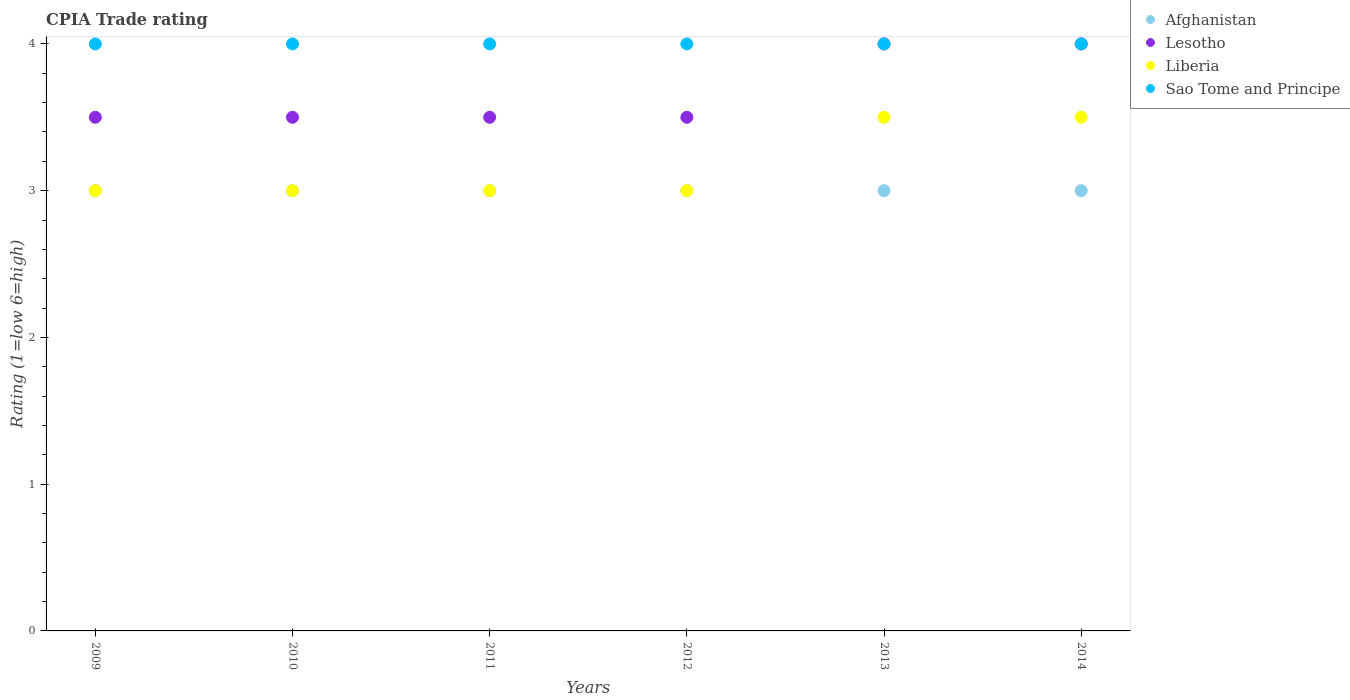How many different coloured dotlines are there?
Offer a terse response. 4. Across all years, what is the maximum CPIA rating in Sao Tome and Principe?
Provide a succinct answer. 4. Across all years, what is the minimum CPIA rating in Sao Tome and Principe?
Your answer should be compact. 4. In which year was the CPIA rating in Afghanistan maximum?
Provide a short and direct response. 2009. What is the total CPIA rating in Afghanistan in the graph?
Offer a terse response. 18. What is the difference between the CPIA rating in Lesotho in 2011 and that in 2014?
Ensure brevity in your answer.  -0.5. What is the difference between the CPIA rating in Lesotho in 2010 and the CPIA rating in Liberia in 2009?
Offer a very short reply. 0.5. In how many years, is the CPIA rating in Sao Tome and Principe greater than 0.6000000000000001?
Keep it short and to the point. 6. What is the ratio of the CPIA rating in Sao Tome and Principe in 2011 to that in 2012?
Offer a very short reply. 1. Is the difference between the CPIA rating in Lesotho in 2009 and 2011 greater than the difference between the CPIA rating in Afghanistan in 2009 and 2011?
Your answer should be compact. No. What is the difference between the highest and the lowest CPIA rating in Afghanistan?
Your response must be concise. 0. In how many years, is the CPIA rating in Liberia greater than the average CPIA rating in Liberia taken over all years?
Make the answer very short. 2. Does the CPIA rating in Afghanistan monotonically increase over the years?
Your answer should be very brief. No. How many years are there in the graph?
Give a very brief answer. 6. Does the graph contain grids?
Your answer should be compact. No. How many legend labels are there?
Offer a very short reply. 4. How are the legend labels stacked?
Offer a terse response. Vertical. What is the title of the graph?
Offer a very short reply. CPIA Trade rating. Does "Cyprus" appear as one of the legend labels in the graph?
Your answer should be very brief. No. What is the label or title of the X-axis?
Offer a very short reply. Years. What is the Rating (1=low 6=high) in Afghanistan in 2009?
Make the answer very short. 3. What is the Rating (1=low 6=high) of Liberia in 2009?
Provide a succinct answer. 3. What is the Rating (1=low 6=high) in Sao Tome and Principe in 2009?
Give a very brief answer. 4. What is the Rating (1=low 6=high) of Liberia in 2010?
Ensure brevity in your answer.  3. What is the Rating (1=low 6=high) of Lesotho in 2011?
Keep it short and to the point. 3.5. What is the Rating (1=low 6=high) of Liberia in 2011?
Your response must be concise. 3. What is the Rating (1=low 6=high) in Sao Tome and Principe in 2011?
Make the answer very short. 4. What is the Rating (1=low 6=high) of Afghanistan in 2012?
Give a very brief answer. 3. What is the Rating (1=low 6=high) in Lesotho in 2012?
Give a very brief answer. 3.5. What is the Rating (1=low 6=high) of Sao Tome and Principe in 2012?
Offer a very short reply. 4. What is the Rating (1=low 6=high) in Lesotho in 2013?
Your answer should be very brief. 4. What is the Rating (1=low 6=high) in Liberia in 2013?
Make the answer very short. 3.5. Across all years, what is the maximum Rating (1=low 6=high) of Afghanistan?
Make the answer very short. 3. Across all years, what is the maximum Rating (1=low 6=high) in Lesotho?
Provide a short and direct response. 4. Across all years, what is the maximum Rating (1=low 6=high) of Liberia?
Provide a short and direct response. 3.5. Across all years, what is the minimum Rating (1=low 6=high) of Lesotho?
Your response must be concise. 3.5. Across all years, what is the minimum Rating (1=low 6=high) in Sao Tome and Principe?
Keep it short and to the point. 4. What is the total Rating (1=low 6=high) in Afghanistan in the graph?
Offer a very short reply. 18. What is the difference between the Rating (1=low 6=high) of Afghanistan in 2009 and that in 2010?
Provide a succinct answer. 0. What is the difference between the Rating (1=low 6=high) of Liberia in 2009 and that in 2010?
Your answer should be compact. 0. What is the difference between the Rating (1=low 6=high) in Lesotho in 2009 and that in 2011?
Ensure brevity in your answer.  0. What is the difference between the Rating (1=low 6=high) in Liberia in 2009 and that in 2011?
Provide a succinct answer. 0. What is the difference between the Rating (1=low 6=high) in Sao Tome and Principe in 2009 and that in 2011?
Provide a short and direct response. 0. What is the difference between the Rating (1=low 6=high) in Afghanistan in 2009 and that in 2012?
Ensure brevity in your answer.  0. What is the difference between the Rating (1=low 6=high) of Sao Tome and Principe in 2009 and that in 2012?
Provide a succinct answer. 0. What is the difference between the Rating (1=low 6=high) in Afghanistan in 2009 and that in 2013?
Make the answer very short. 0. What is the difference between the Rating (1=low 6=high) of Liberia in 2009 and that in 2013?
Provide a succinct answer. -0.5. What is the difference between the Rating (1=low 6=high) of Sao Tome and Principe in 2009 and that in 2013?
Provide a succinct answer. 0. What is the difference between the Rating (1=low 6=high) of Afghanistan in 2009 and that in 2014?
Provide a short and direct response. 0. What is the difference between the Rating (1=low 6=high) in Afghanistan in 2010 and that in 2011?
Provide a succinct answer. 0. What is the difference between the Rating (1=low 6=high) of Afghanistan in 2010 and that in 2012?
Ensure brevity in your answer.  0. What is the difference between the Rating (1=low 6=high) of Lesotho in 2010 and that in 2013?
Keep it short and to the point. -0.5. What is the difference between the Rating (1=low 6=high) in Sao Tome and Principe in 2010 and that in 2013?
Your response must be concise. 0. What is the difference between the Rating (1=low 6=high) in Sao Tome and Principe in 2010 and that in 2014?
Offer a terse response. 0. What is the difference between the Rating (1=low 6=high) in Sao Tome and Principe in 2011 and that in 2012?
Make the answer very short. 0. What is the difference between the Rating (1=low 6=high) in Afghanistan in 2011 and that in 2013?
Offer a very short reply. 0. What is the difference between the Rating (1=low 6=high) of Lesotho in 2011 and that in 2013?
Make the answer very short. -0.5. What is the difference between the Rating (1=low 6=high) of Afghanistan in 2011 and that in 2014?
Provide a short and direct response. 0. What is the difference between the Rating (1=low 6=high) in Liberia in 2011 and that in 2014?
Ensure brevity in your answer.  -0.5. What is the difference between the Rating (1=low 6=high) in Sao Tome and Principe in 2011 and that in 2014?
Keep it short and to the point. 0. What is the difference between the Rating (1=low 6=high) in Afghanistan in 2012 and that in 2014?
Give a very brief answer. 0. What is the difference between the Rating (1=low 6=high) of Liberia in 2012 and that in 2014?
Give a very brief answer. -0.5. What is the difference between the Rating (1=low 6=high) in Afghanistan in 2013 and that in 2014?
Offer a terse response. 0. What is the difference between the Rating (1=low 6=high) of Lesotho in 2013 and that in 2014?
Keep it short and to the point. 0. What is the difference between the Rating (1=low 6=high) in Sao Tome and Principe in 2013 and that in 2014?
Make the answer very short. 0. What is the difference between the Rating (1=low 6=high) in Afghanistan in 2009 and the Rating (1=low 6=high) in Lesotho in 2010?
Make the answer very short. -0.5. What is the difference between the Rating (1=low 6=high) in Afghanistan in 2009 and the Rating (1=low 6=high) in Sao Tome and Principe in 2010?
Keep it short and to the point. -1. What is the difference between the Rating (1=low 6=high) in Lesotho in 2009 and the Rating (1=low 6=high) in Liberia in 2010?
Make the answer very short. 0.5. What is the difference between the Rating (1=low 6=high) of Afghanistan in 2009 and the Rating (1=low 6=high) of Sao Tome and Principe in 2011?
Make the answer very short. -1. What is the difference between the Rating (1=low 6=high) in Lesotho in 2009 and the Rating (1=low 6=high) in Liberia in 2011?
Provide a succinct answer. 0.5. What is the difference between the Rating (1=low 6=high) of Lesotho in 2009 and the Rating (1=low 6=high) of Liberia in 2012?
Your response must be concise. 0.5. What is the difference between the Rating (1=low 6=high) in Afghanistan in 2009 and the Rating (1=low 6=high) in Lesotho in 2013?
Make the answer very short. -1. What is the difference between the Rating (1=low 6=high) of Lesotho in 2009 and the Rating (1=low 6=high) of Liberia in 2013?
Ensure brevity in your answer.  0. What is the difference between the Rating (1=low 6=high) of Liberia in 2009 and the Rating (1=low 6=high) of Sao Tome and Principe in 2013?
Offer a terse response. -1. What is the difference between the Rating (1=low 6=high) of Afghanistan in 2009 and the Rating (1=low 6=high) of Sao Tome and Principe in 2014?
Provide a succinct answer. -1. What is the difference between the Rating (1=low 6=high) of Lesotho in 2009 and the Rating (1=low 6=high) of Liberia in 2014?
Your answer should be very brief. 0. What is the difference between the Rating (1=low 6=high) in Lesotho in 2009 and the Rating (1=low 6=high) in Sao Tome and Principe in 2014?
Provide a short and direct response. -0.5. What is the difference between the Rating (1=low 6=high) in Liberia in 2009 and the Rating (1=low 6=high) in Sao Tome and Principe in 2014?
Keep it short and to the point. -1. What is the difference between the Rating (1=low 6=high) of Afghanistan in 2010 and the Rating (1=low 6=high) of Liberia in 2011?
Provide a short and direct response. 0. What is the difference between the Rating (1=low 6=high) of Liberia in 2010 and the Rating (1=low 6=high) of Sao Tome and Principe in 2011?
Offer a terse response. -1. What is the difference between the Rating (1=low 6=high) of Afghanistan in 2010 and the Rating (1=low 6=high) of Lesotho in 2012?
Ensure brevity in your answer.  -0.5. What is the difference between the Rating (1=low 6=high) in Afghanistan in 2010 and the Rating (1=low 6=high) in Sao Tome and Principe in 2012?
Offer a terse response. -1. What is the difference between the Rating (1=low 6=high) of Lesotho in 2010 and the Rating (1=low 6=high) of Liberia in 2012?
Offer a very short reply. 0.5. What is the difference between the Rating (1=low 6=high) of Lesotho in 2010 and the Rating (1=low 6=high) of Sao Tome and Principe in 2012?
Make the answer very short. -0.5. What is the difference between the Rating (1=low 6=high) in Liberia in 2010 and the Rating (1=low 6=high) in Sao Tome and Principe in 2012?
Offer a very short reply. -1. What is the difference between the Rating (1=low 6=high) in Afghanistan in 2010 and the Rating (1=low 6=high) in Liberia in 2013?
Provide a succinct answer. -0.5. What is the difference between the Rating (1=low 6=high) of Lesotho in 2010 and the Rating (1=low 6=high) of Sao Tome and Principe in 2013?
Your response must be concise. -0.5. What is the difference between the Rating (1=low 6=high) of Afghanistan in 2010 and the Rating (1=low 6=high) of Liberia in 2014?
Make the answer very short. -0.5. What is the difference between the Rating (1=low 6=high) in Afghanistan in 2011 and the Rating (1=low 6=high) in Sao Tome and Principe in 2012?
Your answer should be compact. -1. What is the difference between the Rating (1=low 6=high) in Lesotho in 2011 and the Rating (1=low 6=high) in Liberia in 2012?
Give a very brief answer. 0.5. What is the difference between the Rating (1=low 6=high) in Afghanistan in 2011 and the Rating (1=low 6=high) in Liberia in 2013?
Provide a succinct answer. -0.5. What is the difference between the Rating (1=low 6=high) in Lesotho in 2011 and the Rating (1=low 6=high) in Liberia in 2013?
Provide a short and direct response. 0. What is the difference between the Rating (1=low 6=high) in Lesotho in 2011 and the Rating (1=low 6=high) in Sao Tome and Principe in 2013?
Offer a terse response. -0.5. What is the difference between the Rating (1=low 6=high) of Liberia in 2011 and the Rating (1=low 6=high) of Sao Tome and Principe in 2013?
Keep it short and to the point. -1. What is the difference between the Rating (1=low 6=high) of Afghanistan in 2011 and the Rating (1=low 6=high) of Lesotho in 2014?
Provide a succinct answer. -1. What is the difference between the Rating (1=low 6=high) of Afghanistan in 2011 and the Rating (1=low 6=high) of Liberia in 2014?
Your answer should be very brief. -0.5. What is the difference between the Rating (1=low 6=high) of Afghanistan in 2011 and the Rating (1=low 6=high) of Sao Tome and Principe in 2014?
Give a very brief answer. -1. What is the difference between the Rating (1=low 6=high) in Lesotho in 2011 and the Rating (1=low 6=high) in Sao Tome and Principe in 2014?
Your response must be concise. -0.5. What is the difference between the Rating (1=low 6=high) in Afghanistan in 2012 and the Rating (1=low 6=high) in Sao Tome and Principe in 2013?
Make the answer very short. -1. What is the difference between the Rating (1=low 6=high) of Afghanistan in 2012 and the Rating (1=low 6=high) of Lesotho in 2014?
Your answer should be very brief. -1. What is the difference between the Rating (1=low 6=high) in Afghanistan in 2012 and the Rating (1=low 6=high) in Liberia in 2014?
Keep it short and to the point. -0.5. What is the difference between the Rating (1=low 6=high) in Lesotho in 2012 and the Rating (1=low 6=high) in Sao Tome and Principe in 2014?
Provide a succinct answer. -0.5. What is the difference between the Rating (1=low 6=high) of Liberia in 2013 and the Rating (1=low 6=high) of Sao Tome and Principe in 2014?
Provide a succinct answer. -0.5. What is the average Rating (1=low 6=high) of Lesotho per year?
Offer a terse response. 3.67. What is the average Rating (1=low 6=high) of Liberia per year?
Offer a very short reply. 3.17. In the year 2009, what is the difference between the Rating (1=low 6=high) in Lesotho and Rating (1=low 6=high) in Liberia?
Ensure brevity in your answer.  0.5. In the year 2009, what is the difference between the Rating (1=low 6=high) of Liberia and Rating (1=low 6=high) of Sao Tome and Principe?
Your response must be concise. -1. In the year 2010, what is the difference between the Rating (1=low 6=high) of Liberia and Rating (1=low 6=high) of Sao Tome and Principe?
Your answer should be compact. -1. In the year 2011, what is the difference between the Rating (1=low 6=high) of Afghanistan and Rating (1=low 6=high) of Lesotho?
Provide a succinct answer. -0.5. In the year 2011, what is the difference between the Rating (1=low 6=high) of Lesotho and Rating (1=low 6=high) of Liberia?
Your response must be concise. 0.5. In the year 2011, what is the difference between the Rating (1=low 6=high) of Liberia and Rating (1=low 6=high) of Sao Tome and Principe?
Keep it short and to the point. -1. In the year 2012, what is the difference between the Rating (1=low 6=high) in Lesotho and Rating (1=low 6=high) in Sao Tome and Principe?
Offer a very short reply. -0.5. In the year 2012, what is the difference between the Rating (1=low 6=high) in Liberia and Rating (1=low 6=high) in Sao Tome and Principe?
Offer a very short reply. -1. In the year 2013, what is the difference between the Rating (1=low 6=high) in Afghanistan and Rating (1=low 6=high) in Lesotho?
Make the answer very short. -1. In the year 2013, what is the difference between the Rating (1=low 6=high) of Afghanistan and Rating (1=low 6=high) of Sao Tome and Principe?
Give a very brief answer. -1. In the year 2013, what is the difference between the Rating (1=low 6=high) in Lesotho and Rating (1=low 6=high) in Liberia?
Your response must be concise. 0.5. In the year 2013, what is the difference between the Rating (1=low 6=high) of Liberia and Rating (1=low 6=high) of Sao Tome and Principe?
Your answer should be compact. -0.5. In the year 2014, what is the difference between the Rating (1=low 6=high) in Afghanistan and Rating (1=low 6=high) in Liberia?
Give a very brief answer. -0.5. In the year 2014, what is the difference between the Rating (1=low 6=high) in Lesotho and Rating (1=low 6=high) in Liberia?
Provide a succinct answer. 0.5. What is the ratio of the Rating (1=low 6=high) in Afghanistan in 2009 to that in 2010?
Provide a succinct answer. 1. What is the ratio of the Rating (1=low 6=high) of Liberia in 2009 to that in 2010?
Make the answer very short. 1. What is the ratio of the Rating (1=low 6=high) in Liberia in 2009 to that in 2011?
Provide a succinct answer. 1. What is the ratio of the Rating (1=low 6=high) of Afghanistan in 2009 to that in 2012?
Offer a terse response. 1. What is the ratio of the Rating (1=low 6=high) of Lesotho in 2009 to that in 2012?
Your response must be concise. 1. What is the ratio of the Rating (1=low 6=high) in Liberia in 2009 to that in 2012?
Your answer should be very brief. 1. What is the ratio of the Rating (1=low 6=high) in Sao Tome and Principe in 2009 to that in 2012?
Offer a very short reply. 1. What is the ratio of the Rating (1=low 6=high) in Afghanistan in 2009 to that in 2013?
Ensure brevity in your answer.  1. What is the ratio of the Rating (1=low 6=high) in Liberia in 2009 to that in 2013?
Your answer should be compact. 0.86. What is the ratio of the Rating (1=low 6=high) in Sao Tome and Principe in 2009 to that in 2013?
Ensure brevity in your answer.  1. What is the ratio of the Rating (1=low 6=high) of Afghanistan in 2009 to that in 2014?
Your answer should be compact. 1. What is the ratio of the Rating (1=low 6=high) in Lesotho in 2009 to that in 2014?
Your answer should be compact. 0.88. What is the ratio of the Rating (1=low 6=high) of Sao Tome and Principe in 2009 to that in 2014?
Give a very brief answer. 1. What is the ratio of the Rating (1=low 6=high) in Afghanistan in 2010 to that in 2011?
Give a very brief answer. 1. What is the ratio of the Rating (1=low 6=high) of Lesotho in 2010 to that in 2011?
Provide a succinct answer. 1. What is the ratio of the Rating (1=low 6=high) in Afghanistan in 2010 to that in 2012?
Provide a succinct answer. 1. What is the ratio of the Rating (1=low 6=high) of Liberia in 2010 to that in 2012?
Your response must be concise. 1. What is the ratio of the Rating (1=low 6=high) of Sao Tome and Principe in 2010 to that in 2012?
Your response must be concise. 1. What is the ratio of the Rating (1=low 6=high) in Lesotho in 2010 to that in 2013?
Make the answer very short. 0.88. What is the ratio of the Rating (1=low 6=high) of Liberia in 2010 to that in 2013?
Ensure brevity in your answer.  0.86. What is the ratio of the Rating (1=low 6=high) in Afghanistan in 2010 to that in 2014?
Ensure brevity in your answer.  1. What is the ratio of the Rating (1=low 6=high) of Liberia in 2010 to that in 2014?
Keep it short and to the point. 0.86. What is the ratio of the Rating (1=low 6=high) of Afghanistan in 2011 to that in 2012?
Make the answer very short. 1. What is the ratio of the Rating (1=low 6=high) of Lesotho in 2011 to that in 2012?
Provide a succinct answer. 1. What is the ratio of the Rating (1=low 6=high) of Liberia in 2011 to that in 2012?
Provide a short and direct response. 1. What is the ratio of the Rating (1=low 6=high) of Lesotho in 2011 to that in 2013?
Make the answer very short. 0.88. What is the ratio of the Rating (1=low 6=high) in Liberia in 2011 to that in 2013?
Offer a very short reply. 0.86. What is the ratio of the Rating (1=low 6=high) of Sao Tome and Principe in 2011 to that in 2013?
Ensure brevity in your answer.  1. What is the ratio of the Rating (1=low 6=high) of Lesotho in 2012 to that in 2013?
Your answer should be compact. 0.88. What is the ratio of the Rating (1=low 6=high) of Afghanistan in 2012 to that in 2014?
Keep it short and to the point. 1. What is the ratio of the Rating (1=low 6=high) in Lesotho in 2012 to that in 2014?
Your response must be concise. 0.88. What is the ratio of the Rating (1=low 6=high) of Sao Tome and Principe in 2012 to that in 2014?
Offer a terse response. 1. What is the ratio of the Rating (1=low 6=high) of Lesotho in 2013 to that in 2014?
Your answer should be very brief. 1. What is the ratio of the Rating (1=low 6=high) of Sao Tome and Principe in 2013 to that in 2014?
Provide a short and direct response. 1. What is the difference between the highest and the second highest Rating (1=low 6=high) in Liberia?
Your response must be concise. 0. What is the difference between the highest and the second highest Rating (1=low 6=high) of Sao Tome and Principe?
Make the answer very short. 0. What is the difference between the highest and the lowest Rating (1=low 6=high) of Lesotho?
Your answer should be compact. 0.5. What is the difference between the highest and the lowest Rating (1=low 6=high) in Liberia?
Give a very brief answer. 0.5. 